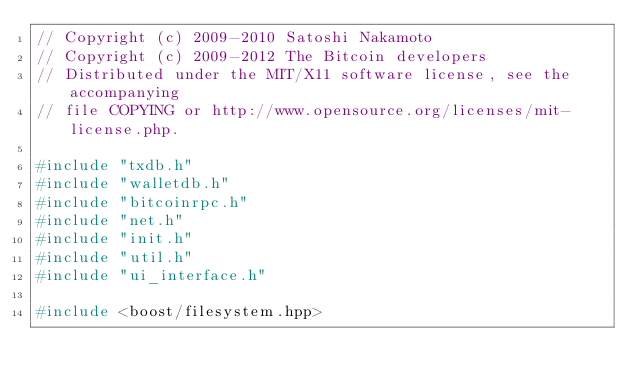<code> <loc_0><loc_0><loc_500><loc_500><_C++_>// Copyright (c) 2009-2010 Satoshi Nakamoto
// Copyright (c) 2009-2012 The Bitcoin developers
// Distributed under the MIT/X11 software license, see the accompanying
// file COPYING or http://www.opensource.org/licenses/mit-license.php.

#include "txdb.h"
#include "walletdb.h"
#include "bitcoinrpc.h"
#include "net.h"
#include "init.h"
#include "util.h"
#include "ui_interface.h"

#include <boost/filesystem.hpp></code> 